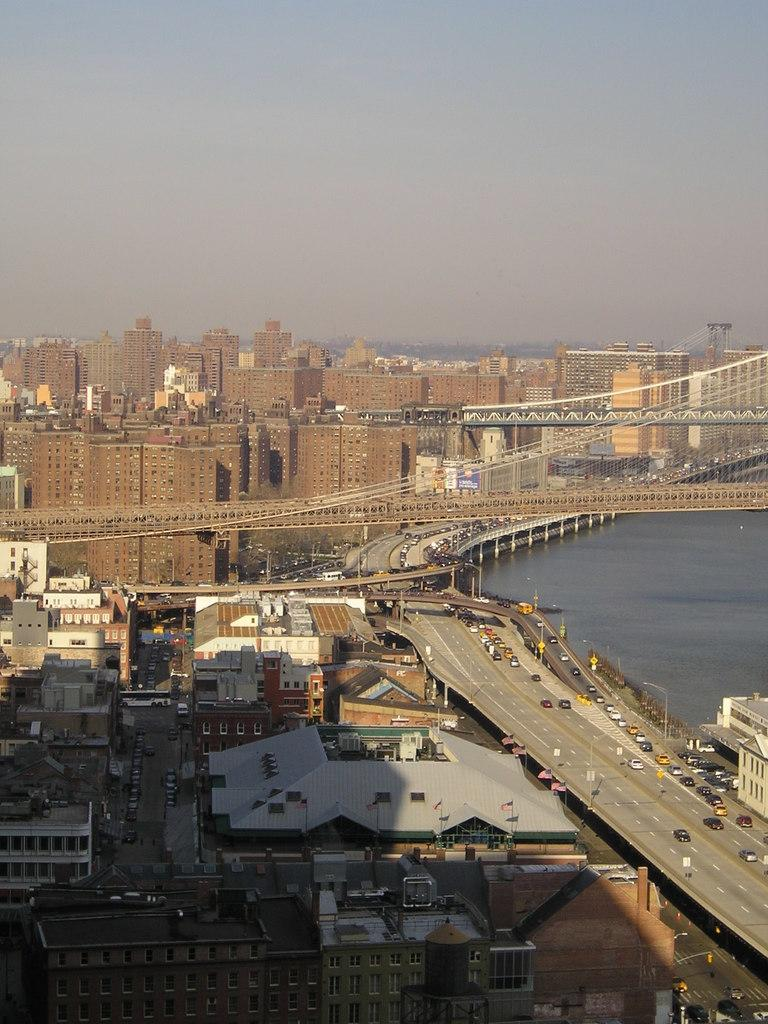What type of structures can be seen in the image? There are buildings in the image. What feature is visible on the buildings? There are windows visible in the image. What type of infrastructure is present in the image? There are light poles and bridges in the image. What natural element is visible in the image? There is water visible in the image. What type of transportation is present in the image? There are vehicles on the road in the image. What is the color of the sky in the image? The sky is blue and white in color. Can you see any toothpaste floating in the water in the image? There is no toothpaste present in the image. Are there any jellyfish swimming in the water in the image? There are no jellyfish present in the image. 